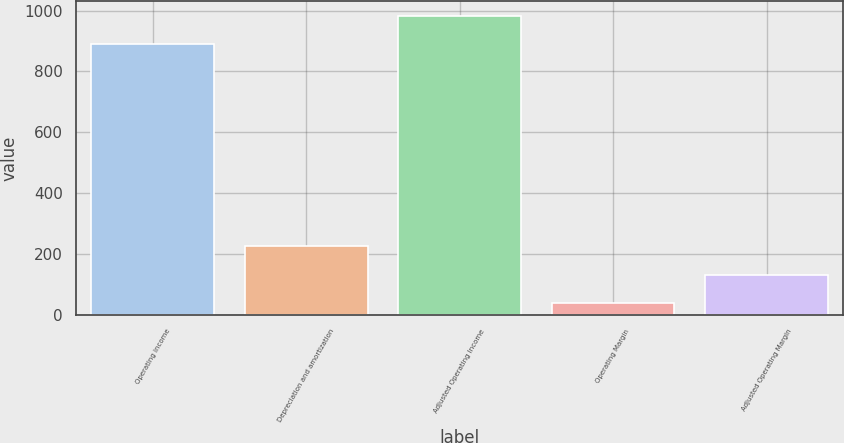Convert chart. <chart><loc_0><loc_0><loc_500><loc_500><bar_chart><fcel>Operating income<fcel>Depreciation and amortization<fcel>Adjusted Operating Income<fcel>Operating Margin<fcel>Adjusted Operating Margin<nl><fcel>888.4<fcel>224.72<fcel>981.26<fcel>39<fcel>131.86<nl></chart> 